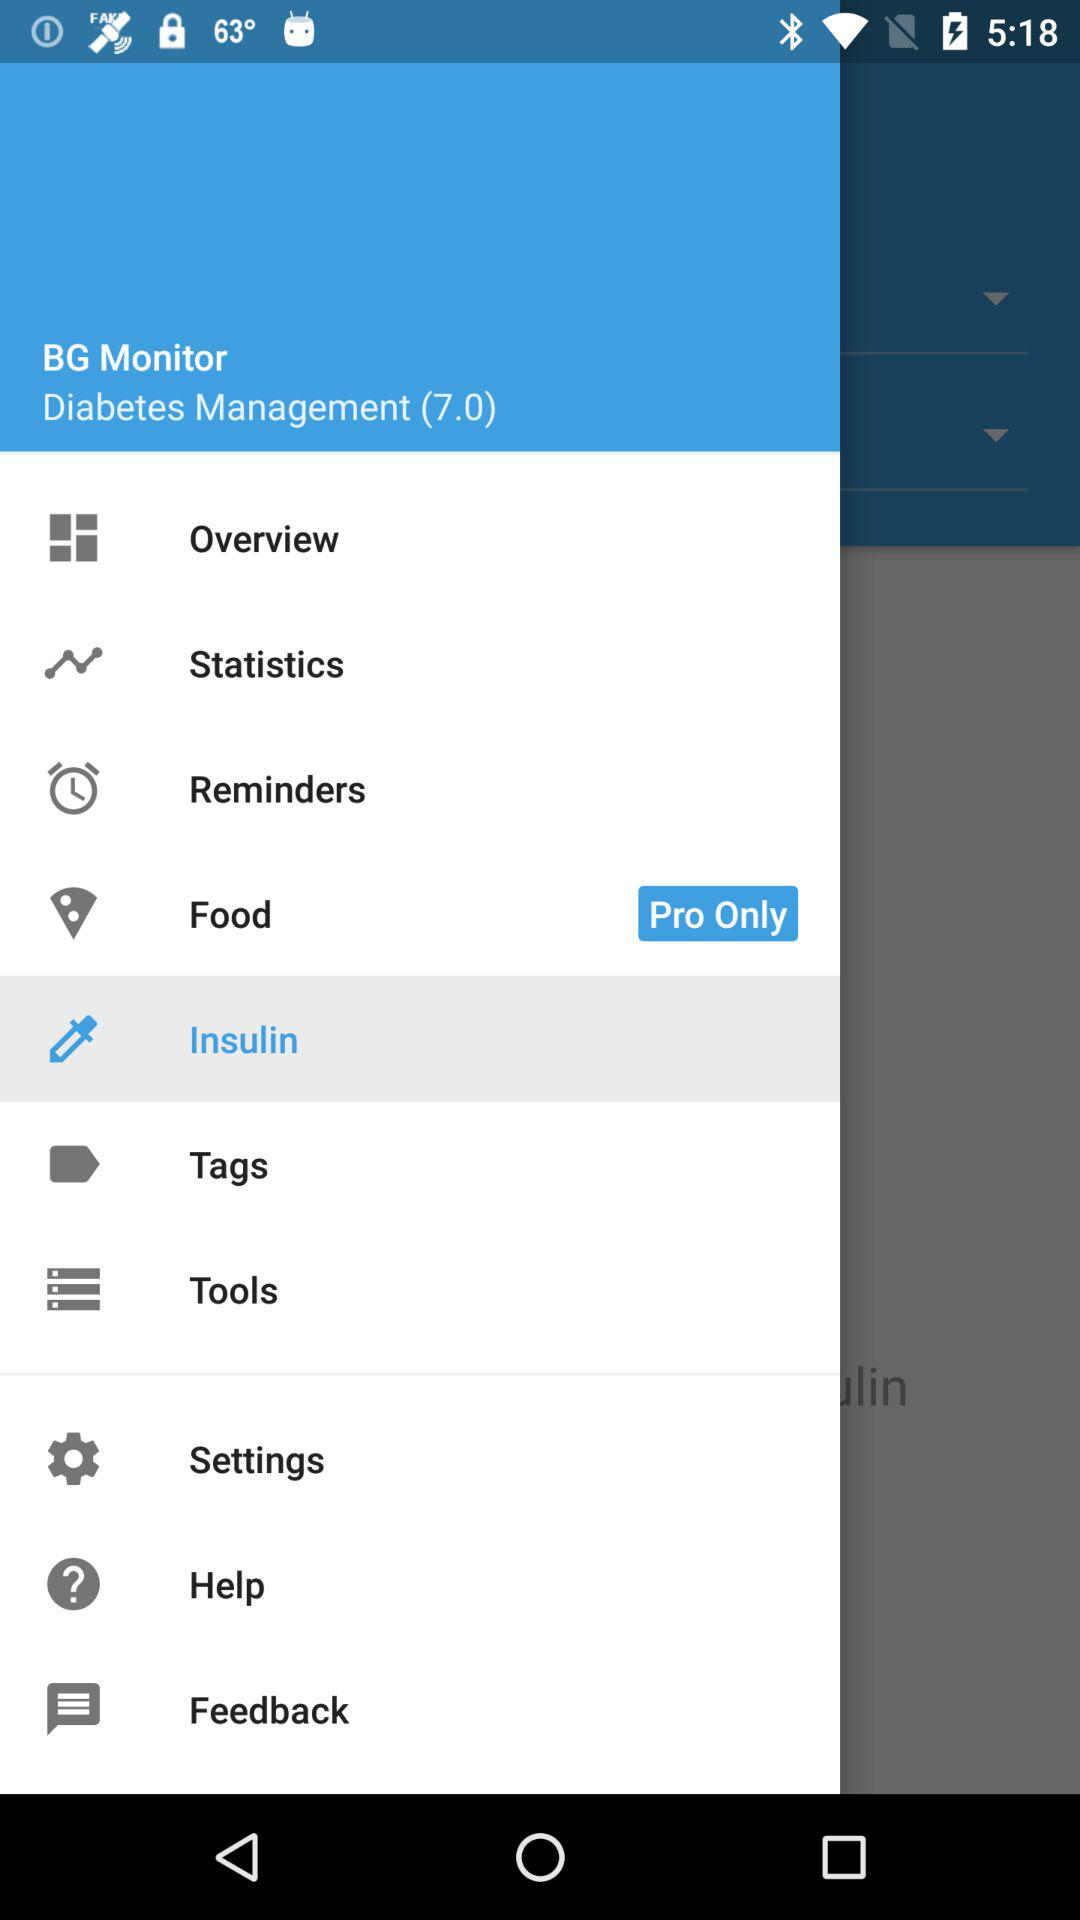What is the version of the application? The version is 7.0. 